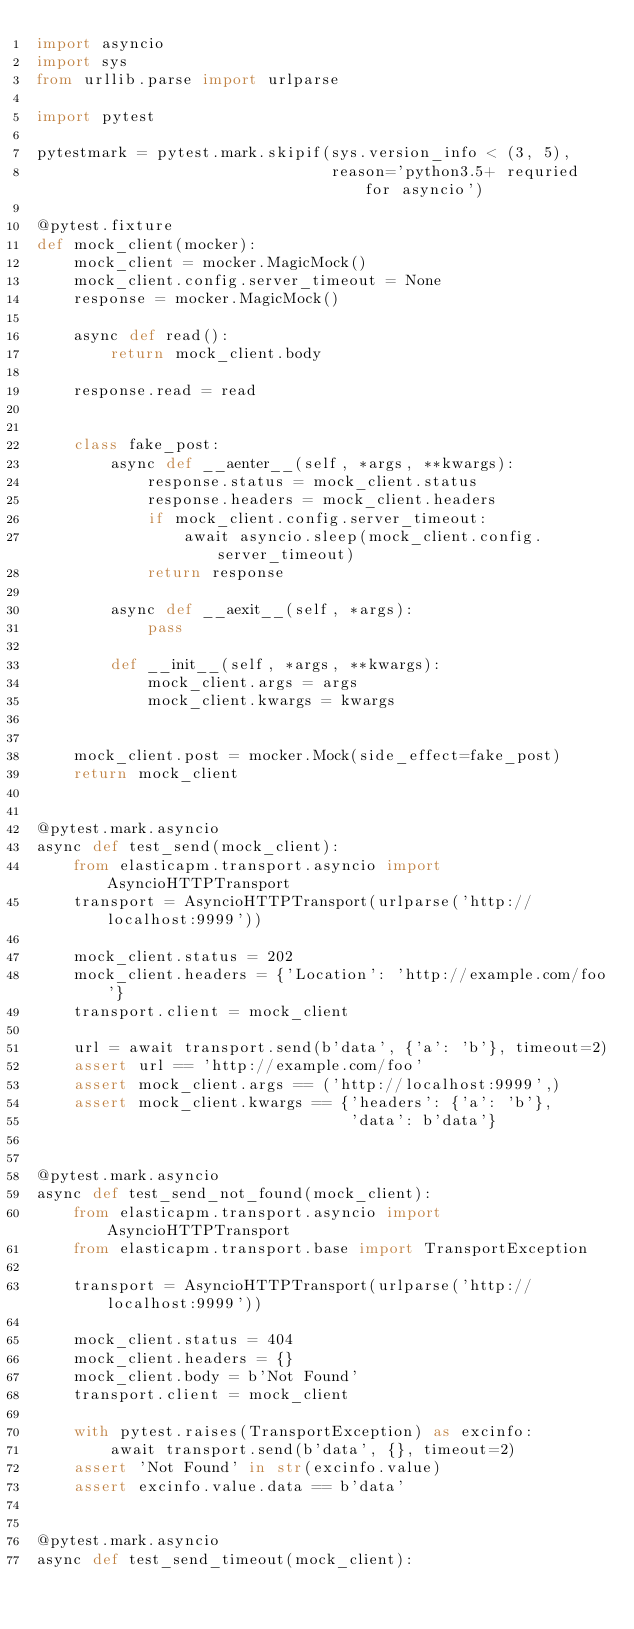<code> <loc_0><loc_0><loc_500><loc_500><_Python_>import asyncio
import sys
from urllib.parse import urlparse

import pytest

pytestmark = pytest.mark.skipif(sys.version_info < (3, 5),
                                reason='python3.5+ requried for asyncio')

@pytest.fixture
def mock_client(mocker):
    mock_client = mocker.MagicMock()
    mock_client.config.server_timeout = None
    response = mocker.MagicMock()

    async def read():
        return mock_client.body

    response.read = read


    class fake_post:
        async def __aenter__(self, *args, **kwargs):
            response.status = mock_client.status
            response.headers = mock_client.headers
            if mock_client.config.server_timeout:
                await asyncio.sleep(mock_client.config.server_timeout)
            return response

        async def __aexit__(self, *args):
            pass

        def __init__(self, *args, **kwargs):
            mock_client.args = args
            mock_client.kwargs = kwargs


    mock_client.post = mocker.Mock(side_effect=fake_post)
    return mock_client


@pytest.mark.asyncio
async def test_send(mock_client):
    from elasticapm.transport.asyncio import AsyncioHTTPTransport
    transport = AsyncioHTTPTransport(urlparse('http://localhost:9999'))

    mock_client.status = 202
    mock_client.headers = {'Location': 'http://example.com/foo'}
    transport.client = mock_client

    url = await transport.send(b'data', {'a': 'b'}, timeout=2)
    assert url == 'http://example.com/foo'
    assert mock_client.args == ('http://localhost:9999',)
    assert mock_client.kwargs == {'headers': {'a': 'b'},
                                  'data': b'data'}


@pytest.mark.asyncio
async def test_send_not_found(mock_client):
    from elasticapm.transport.asyncio import AsyncioHTTPTransport
    from elasticapm.transport.base import TransportException

    transport = AsyncioHTTPTransport(urlparse('http://localhost:9999'))

    mock_client.status = 404
    mock_client.headers = {}
    mock_client.body = b'Not Found'
    transport.client = mock_client

    with pytest.raises(TransportException) as excinfo:
        await transport.send(b'data', {}, timeout=2)
    assert 'Not Found' in str(excinfo.value)
    assert excinfo.value.data == b'data'


@pytest.mark.asyncio
async def test_send_timeout(mock_client):</code> 